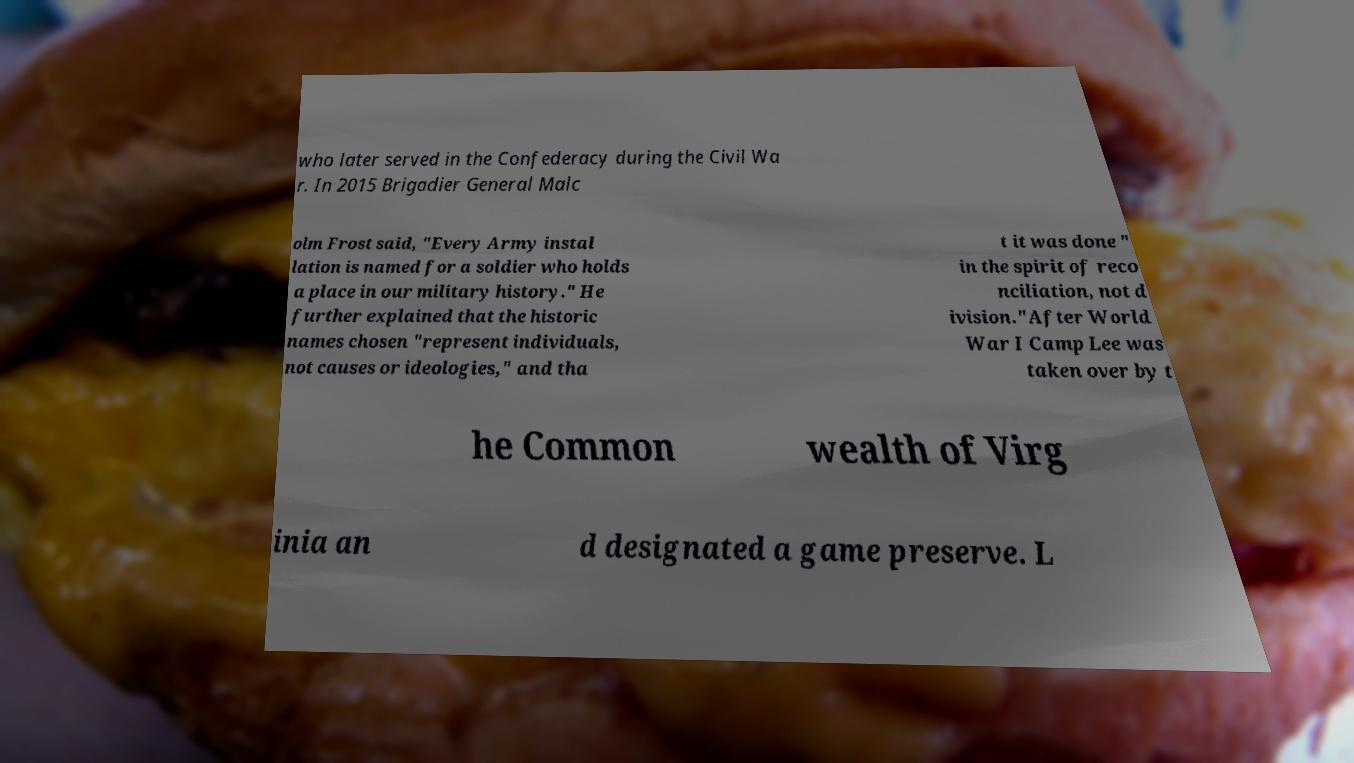Could you assist in decoding the text presented in this image and type it out clearly? who later served in the Confederacy during the Civil Wa r. In 2015 Brigadier General Malc olm Frost said, "Every Army instal lation is named for a soldier who holds a place in our military history." He further explained that the historic names chosen "represent individuals, not causes or ideologies," and tha t it was done " in the spirit of reco nciliation, not d ivision."After World War I Camp Lee was taken over by t he Common wealth of Virg inia an d designated a game preserve. L 